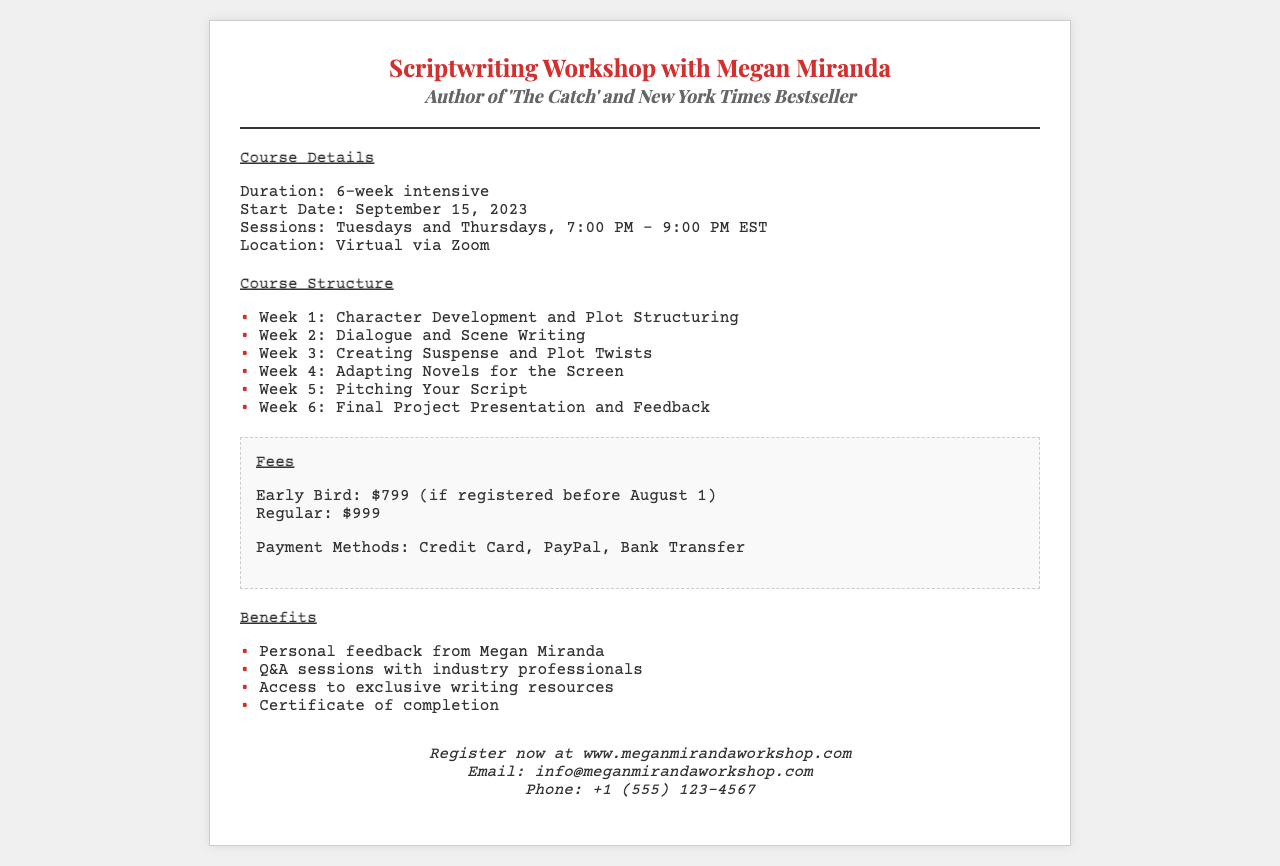What is the duration of the workshop? The duration of the workshop is explicitly mentioned in the document as 6 weeks.
Answer: 6-week intensive What are the workshop start and end dates? The start date is provided as September 15, 2023, and the duration is 6 weeks, making the end date October 27, 2023.
Answer: September 15, 2023 - October 27, 2023 How many sessions are there per week? The document states that there are two sessions each week, on Tuesdays and Thursdays.
Answer: 2 sessions What is the early bird fee? The document clearly states the early bird fee as $799 if registered before August 1.
Answer: $799 Which method of payment is mentioned? The document lists payment methods including Credit Card, PayPal, and Bank Transfer, making this a specific information retrieval question.
Answer: Credit Card, PayPal, Bank Transfer What is one key benefit of attending the workshop? The document outlines various benefits, one being personal feedback from Megan Miranda, highlighting the value of participation.
Answer: Personal feedback from Megan Miranda When are the sessions scheduled? The document indicates the specific days and times for the sessions are every Tuesday and Thursday from 7:00 PM to 9:00 PM EST.
Answer: Tuesdays and Thursdays, 7:00 PM - 9:00 PM EST What is required to receive the certificate of completion? The workshop offers a certificate of completion upon finishing the course. Participants need to complete the workshop to receive it.
Answer: Completion of the workshop 